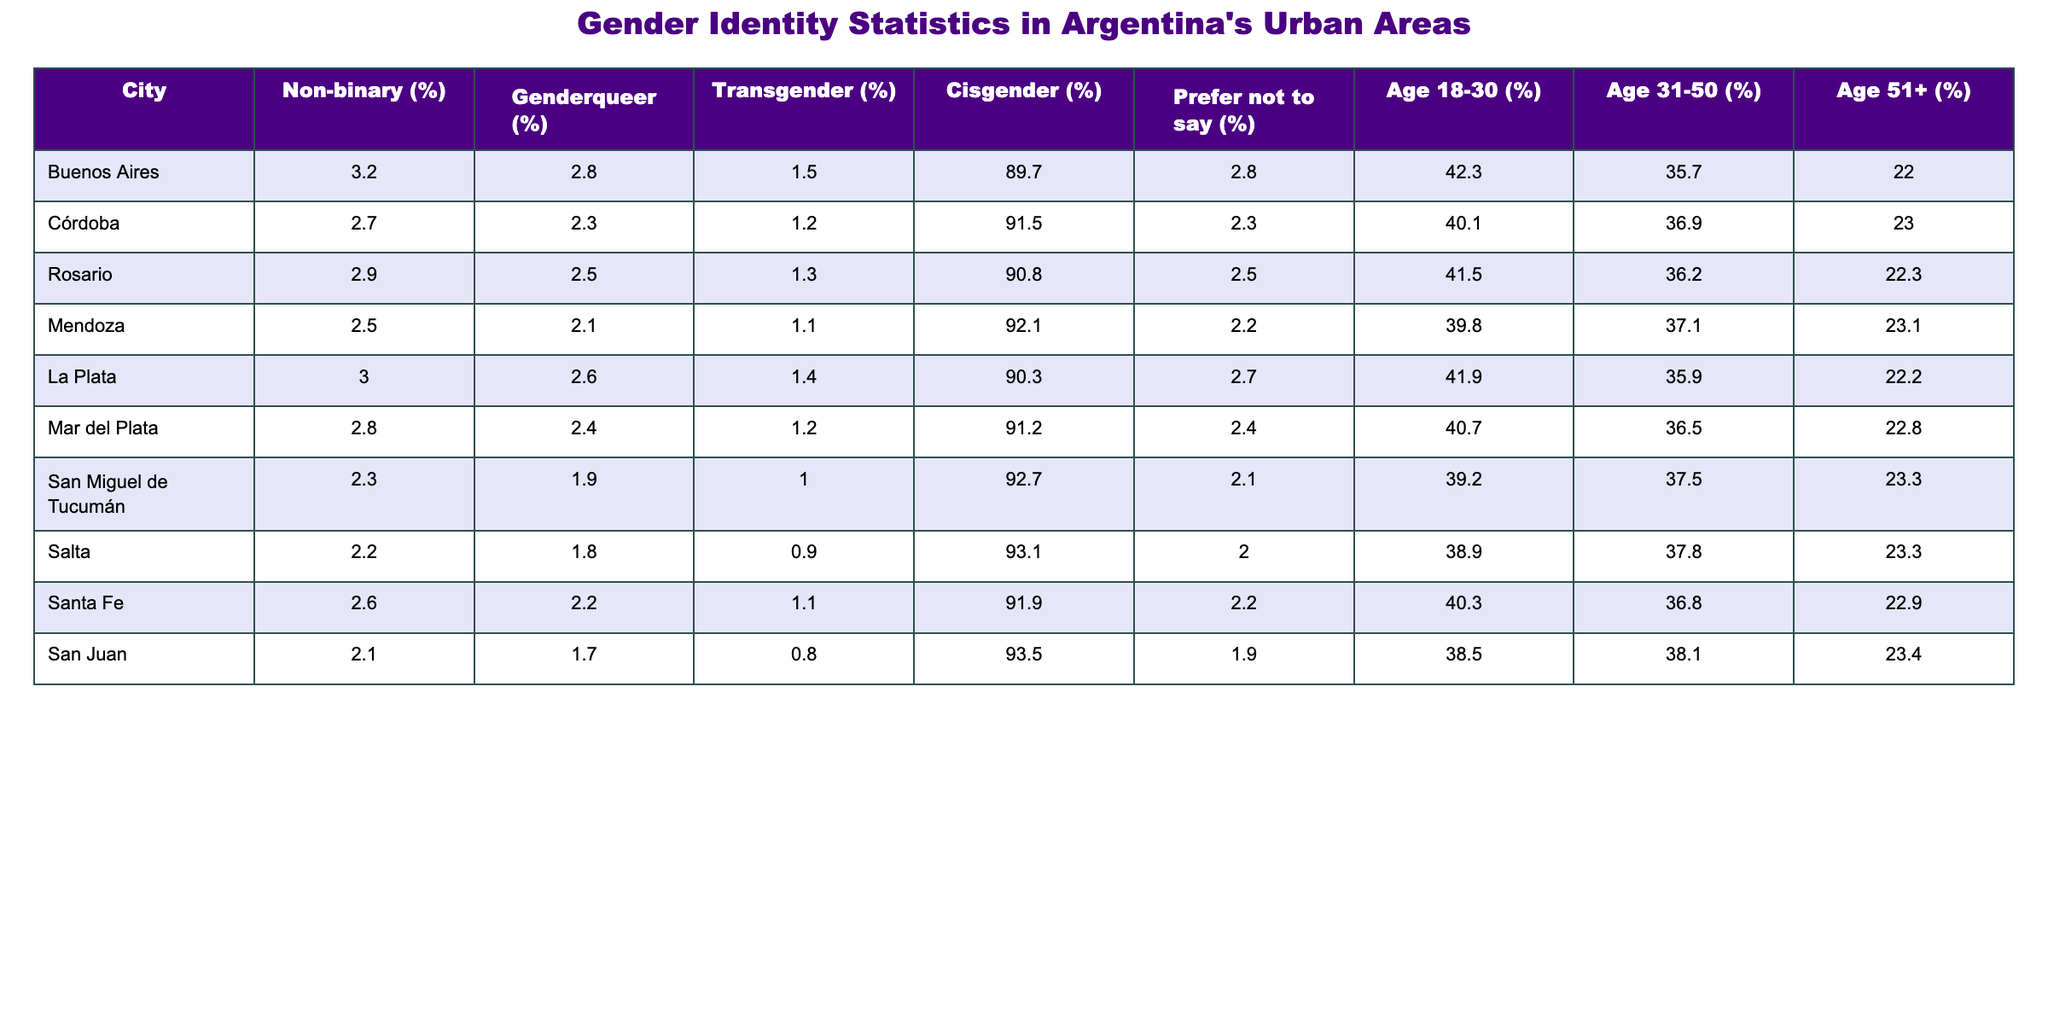What city has the highest percentage of non-binary individuals? By examining the non-binary percentages for each city in the table, Buenos Aires has the highest percentage at 3.2%.
Answer: 3.2% What is the average percentage of genderqueer individuals across the listed cities? To find the average, sum the percentages of genderqueer individuals from all cities: (2.8 + 2.3 + 2.5 + 2.1 + 2.6 + 2.4 + 1.9 + 1.8 + 2.2 + 1.7) = 23.3, then divide by 10: 23.3/10 = 2.33%.
Answer: 2.33% Is there a city where the percentage of transgender individuals is higher than 1.5%? Yes, several cities such as Buenos Aires, Córdoba, Rosario, and La Plata report transgender percentages higher than 1.5%.
Answer: Yes Which city has the lowest percentage of cisgender individuals? The lowest percentage of cisgender individuals is in San Juan, where it is 93.5%.
Answer: 93.5% What is the difference in the percentage of non-binary individuals between Buenos Aires and San Juan? The percentage of non-binary individuals in Buenos Aires is 3.2% while in San Juan it is 2.1%. The difference is 3.2 - 2.1 = 1.1%.
Answer: 1.1% Which age group represents the highest percentage for Mendoza? The age group 18-30 shows the highest percentage at 39.8% for Mendoza.
Answer: 39.8% What proportion of individuals in Rosario prefer not to say their gender identity? The percentage of individuals in Rosario who prefer not to say their gender identity is 2.5%.
Answer: 2.5% Do more individuals in San Miguel de Tucumán identify as non-binary or genderqueer? In San Miguel de Tucumán, the percentage of non-binary individuals is 2.3% and genderqueer is 1.9%. Non-binary individuals are more than genderqueer individuals.
Answer: Non-binary What is the combined percentage of non-binary and genderqueer individuals in Salta? In Salta, the percentages are 2.2% for non-binary and 1.8% for genderqueer. The combined percentage is 2.2 + 1.8 = 4.0%.
Answer: 4.0% What city has the highest representation of those aged 31-50? La Plata has the highest percentage of individuals aged 31-50 at 35.9%.
Answer: 35.9% 